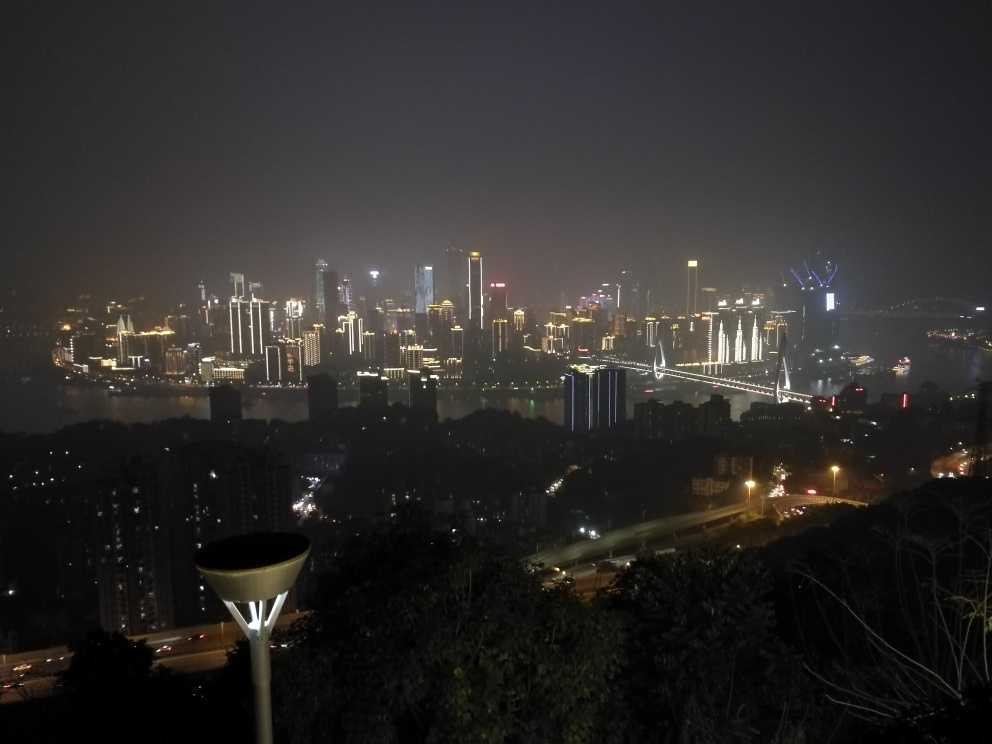Can you describe the weather conditions and how they contribute to the overall mood of the photograph? The weather appears to be slightly hazy or foggy, as indicated by the diffused lighting and soft glow around the lights, which adds an element of mystery to the scene. This weather condition may also symbolize the hustle and bustle of urban life, as it suggests a sense of constant movement and activity. The haziness could reflect the energetic yet chaotic nature of city life, blurring the lines between the natural and artificial environments. 